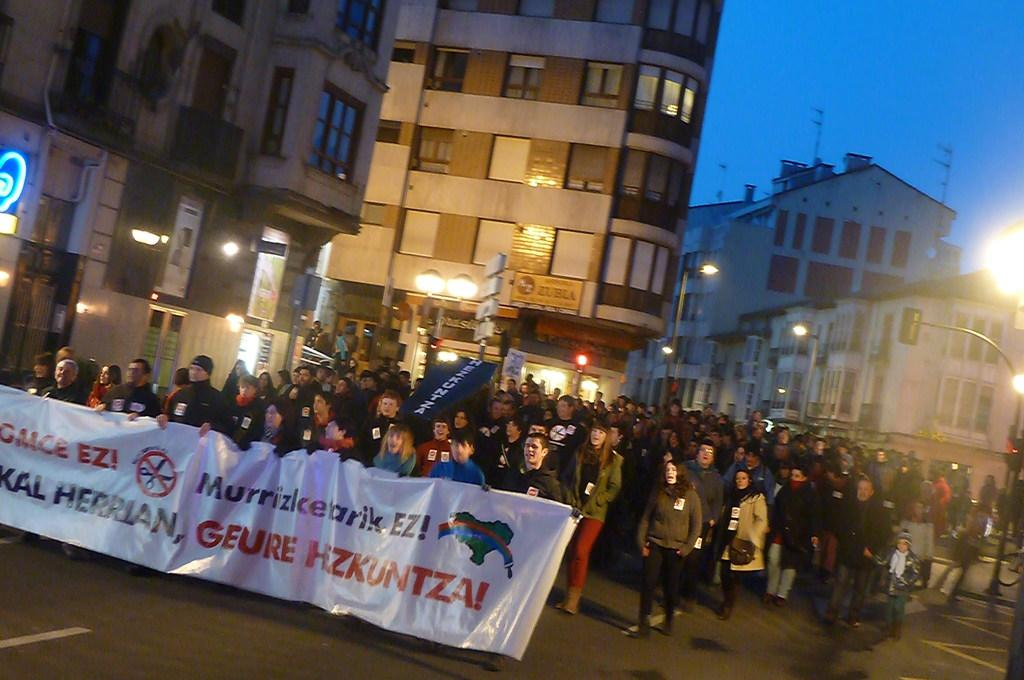Where was the image taken? The image was taken in a street. What are the people in the image doing? The people are walking on the road and holding a banner. What can be seen in the background of the image? There are buildings visible in the background. What part of the natural environment is visible in the image? The sky is visible in the image. What type of dirt can be seen on the people's shoes in the image? There is no dirt visible on the people's shoes in the image. What time of day is it in the image, considering the presence of the night sky? The sky visible in the image is not a night sky, so it is not possible to determine the time of day based on the sky. 